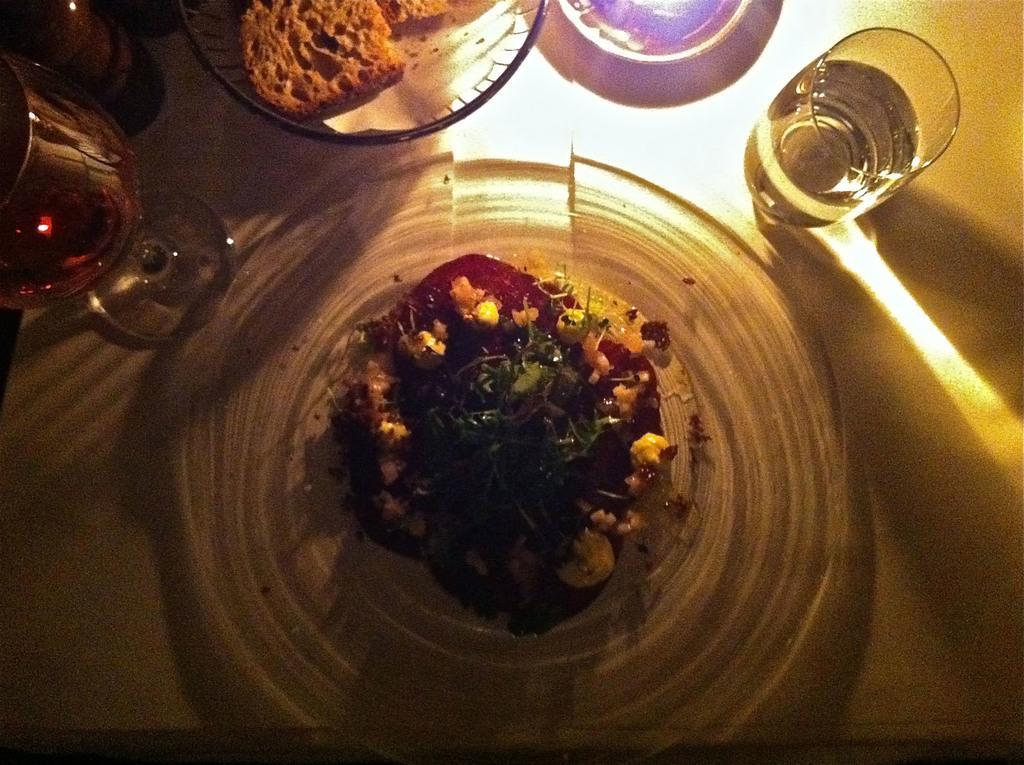Describe this image in one or two sentences. It is a food item in a plate, in the right side. There is water in a glass. 